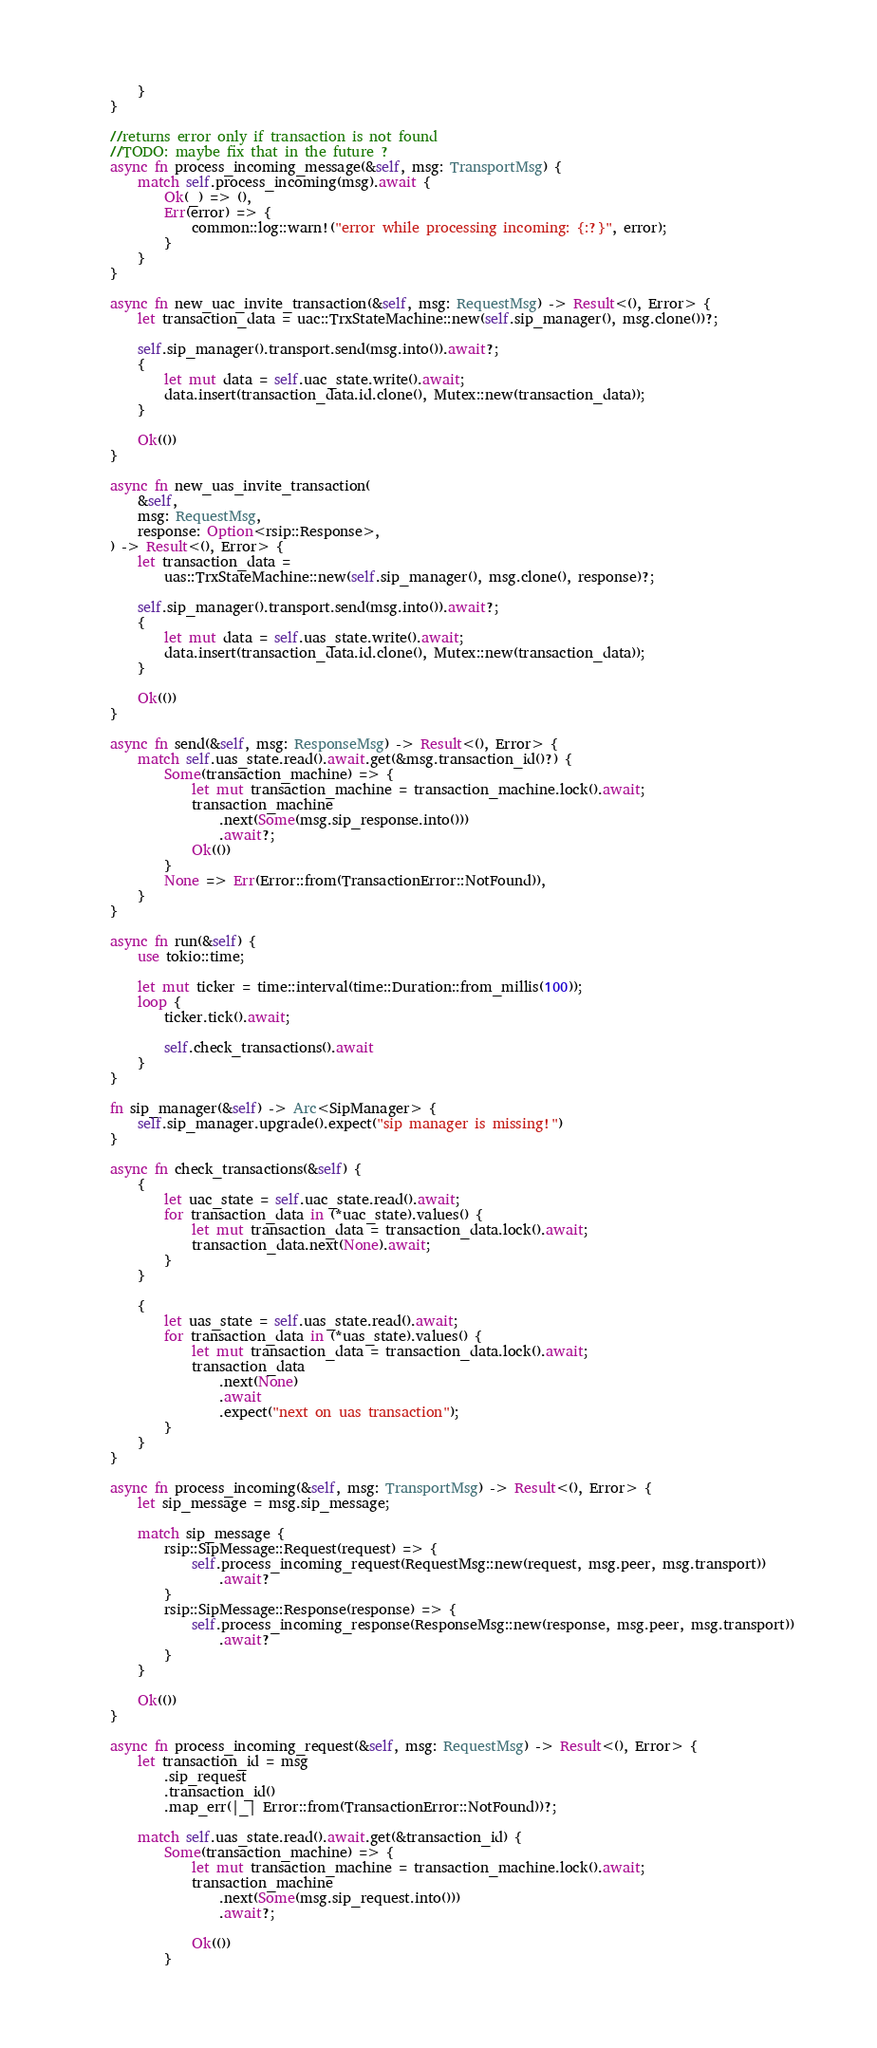<code> <loc_0><loc_0><loc_500><loc_500><_Rust_>        }
    }

    //returns error only if transaction is not found
    //TODO: maybe fix that in the future ?
    async fn process_incoming_message(&self, msg: TransportMsg) {
        match self.process_incoming(msg).await {
            Ok(_) => (),
            Err(error) => {
                common::log::warn!("error while processing incoming: {:?}", error);
            }
        }
    }

    async fn new_uac_invite_transaction(&self, msg: RequestMsg) -> Result<(), Error> {
        let transaction_data = uac::TrxStateMachine::new(self.sip_manager(), msg.clone())?;

        self.sip_manager().transport.send(msg.into()).await?;
        {
            let mut data = self.uac_state.write().await;
            data.insert(transaction_data.id.clone(), Mutex::new(transaction_data));
        }

        Ok(())
    }

    async fn new_uas_invite_transaction(
        &self,
        msg: RequestMsg,
        response: Option<rsip::Response>,
    ) -> Result<(), Error> {
        let transaction_data =
            uas::TrxStateMachine::new(self.sip_manager(), msg.clone(), response)?;

        self.sip_manager().transport.send(msg.into()).await?;
        {
            let mut data = self.uas_state.write().await;
            data.insert(transaction_data.id.clone(), Mutex::new(transaction_data));
        }

        Ok(())
    }

    async fn send(&self, msg: ResponseMsg) -> Result<(), Error> {
        match self.uas_state.read().await.get(&msg.transaction_id()?) {
            Some(transaction_machine) => {
                let mut transaction_machine = transaction_machine.lock().await;
                transaction_machine
                    .next(Some(msg.sip_response.into()))
                    .await?;
                Ok(())
            }
            None => Err(Error::from(TransactionError::NotFound)),
        }
    }

    async fn run(&self) {
        use tokio::time;

        let mut ticker = time::interval(time::Duration::from_millis(100));
        loop {
            ticker.tick().await;

            self.check_transactions().await
        }
    }

    fn sip_manager(&self) -> Arc<SipManager> {
        self.sip_manager.upgrade().expect("sip manager is missing!")
    }

    async fn check_transactions(&self) {
        {
            let uac_state = self.uac_state.read().await;
            for transaction_data in (*uac_state).values() {
                let mut transaction_data = transaction_data.lock().await;
                transaction_data.next(None).await;
            }
        }

        {
            let uas_state = self.uas_state.read().await;
            for transaction_data in (*uas_state).values() {
                let mut transaction_data = transaction_data.lock().await;
                transaction_data
                    .next(None)
                    .await
                    .expect("next on uas transaction");
            }
        }
    }

    async fn process_incoming(&self, msg: TransportMsg) -> Result<(), Error> {
        let sip_message = msg.sip_message;

        match sip_message {
            rsip::SipMessage::Request(request) => {
                self.process_incoming_request(RequestMsg::new(request, msg.peer, msg.transport))
                    .await?
            }
            rsip::SipMessage::Response(response) => {
                self.process_incoming_response(ResponseMsg::new(response, msg.peer, msg.transport))
                    .await?
            }
        }

        Ok(())
    }

    async fn process_incoming_request(&self, msg: RequestMsg) -> Result<(), Error> {
        let transaction_id = msg
            .sip_request
            .transaction_id()
            .map_err(|_| Error::from(TransactionError::NotFound))?;

        match self.uas_state.read().await.get(&transaction_id) {
            Some(transaction_machine) => {
                let mut transaction_machine = transaction_machine.lock().await;
                transaction_machine
                    .next(Some(msg.sip_request.into()))
                    .await?;

                Ok(())
            }</code> 